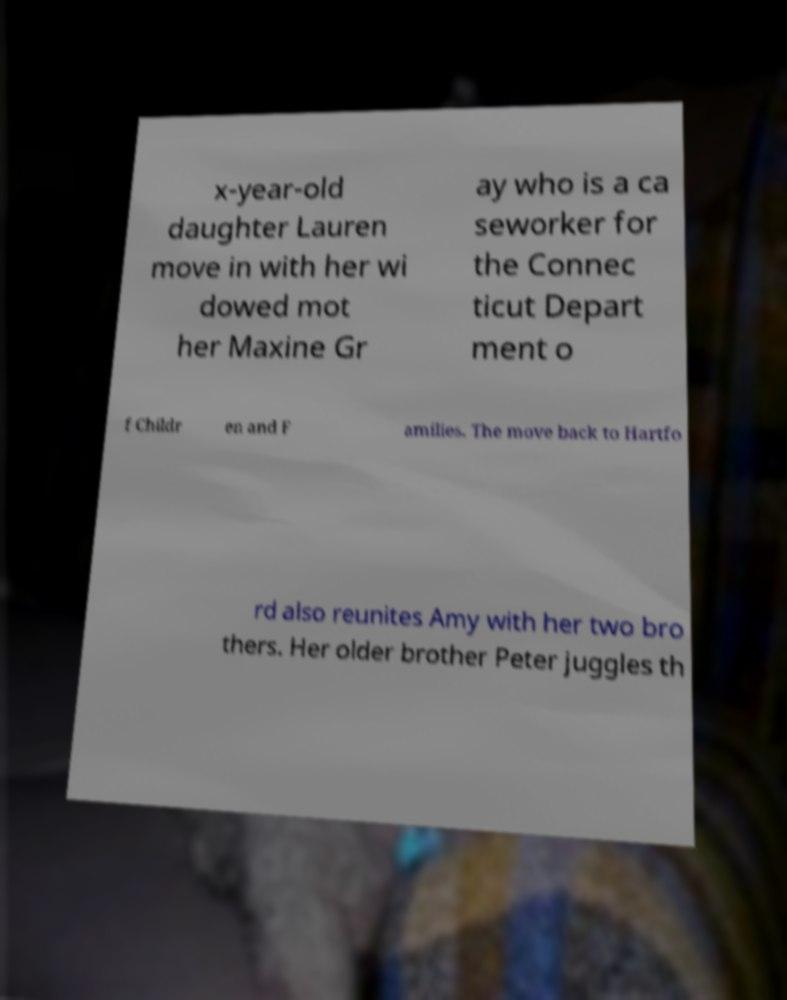Could you extract and type out the text from this image? x-year-old daughter Lauren move in with her wi dowed mot her Maxine Gr ay who is a ca seworker for the Connec ticut Depart ment o f Childr en and F amilies. The move back to Hartfo rd also reunites Amy with her two bro thers. Her older brother Peter juggles th 